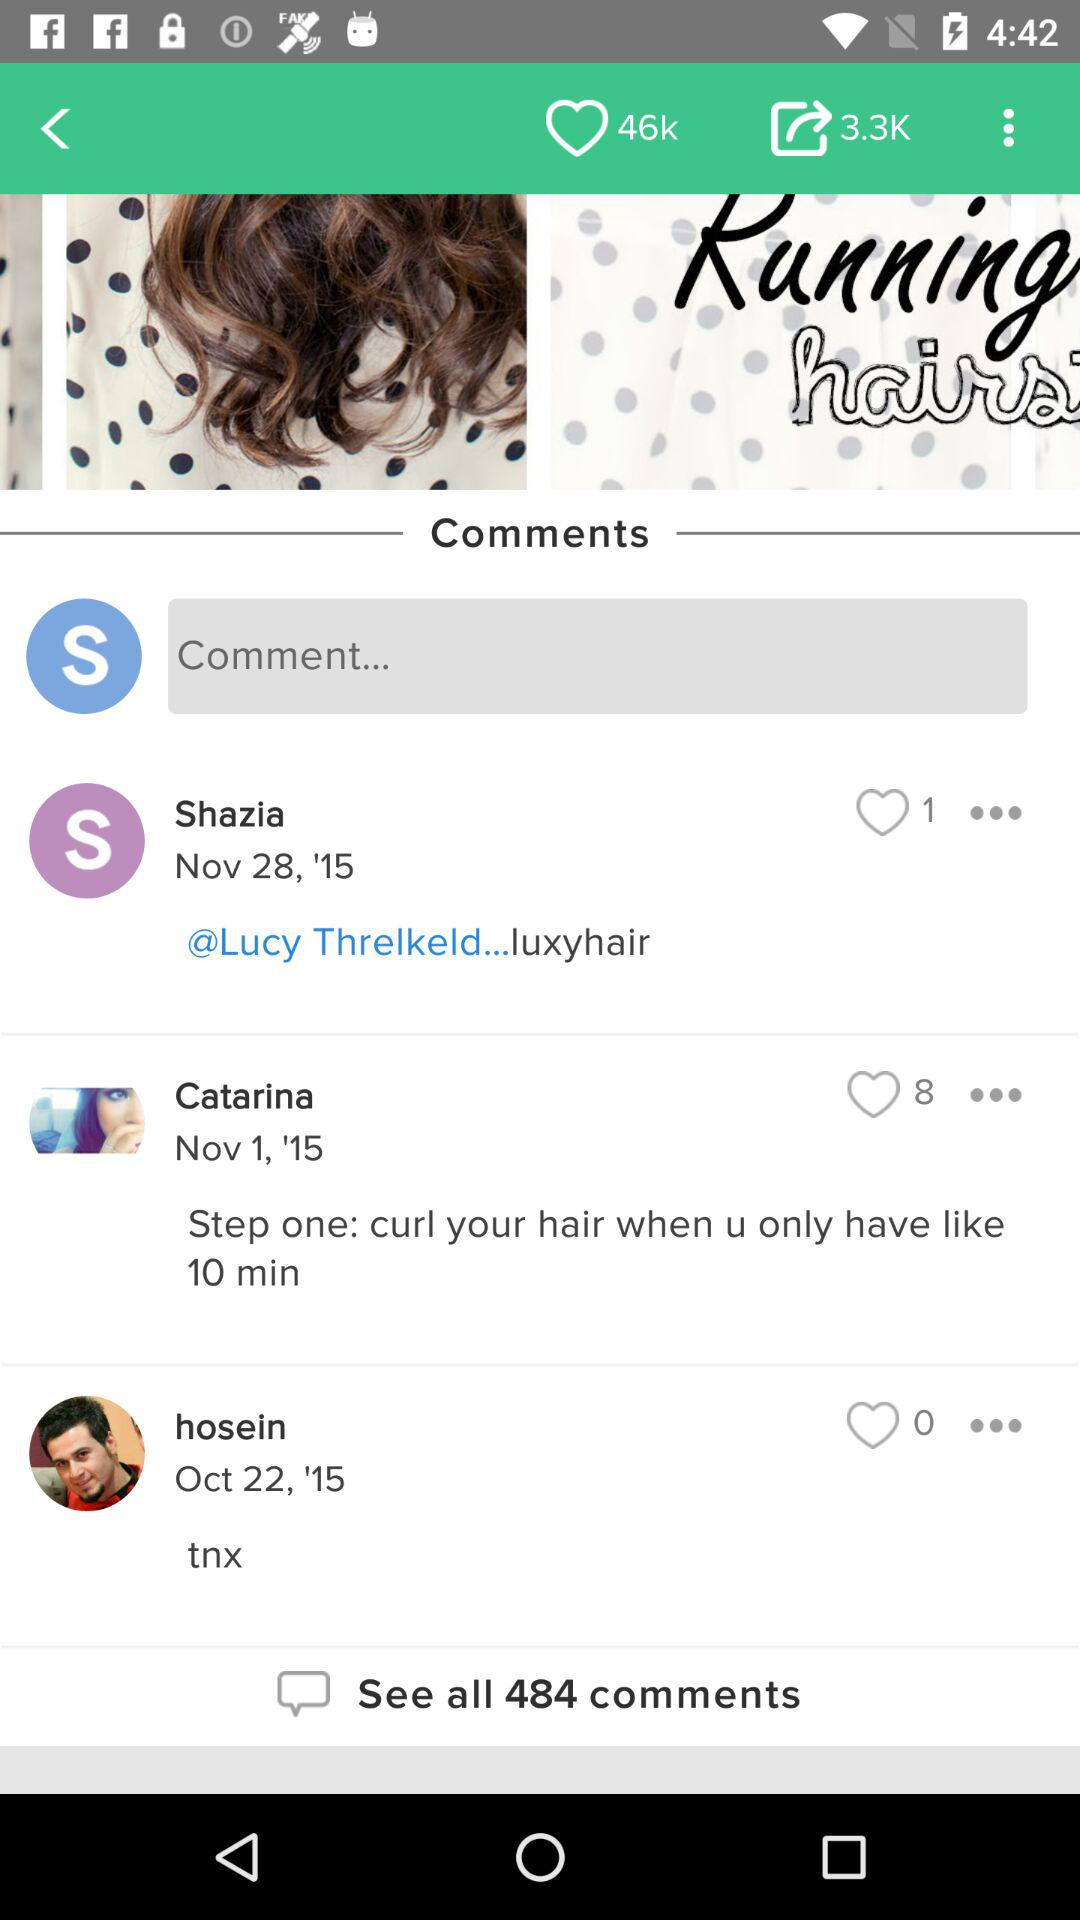How many comments are there?
Answer the question using a single word or phrase. 484 